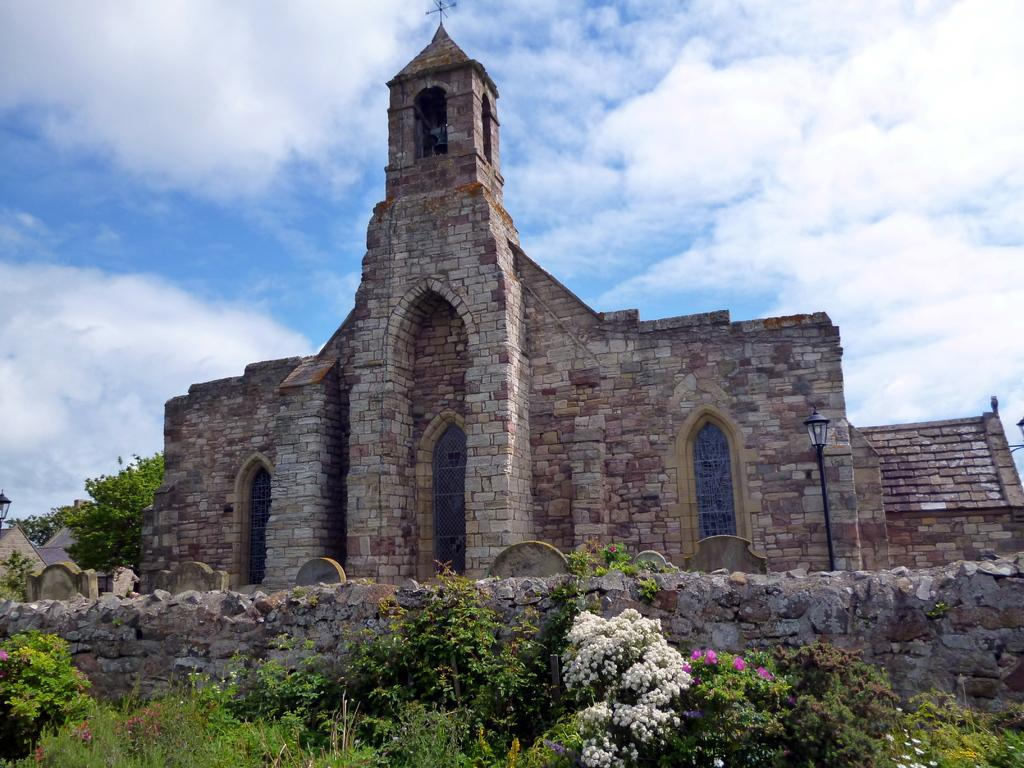What type of plants are at the bottom side of the image? There are flower plants and greenery at the bottom side of the image. What is the main structure in the center of the image? There is a stone castle in the center of the image. What can be seen in the background area of the image? There is a lamp, a tree, and the sky visible in the background area. Where is the cat sitting in the image? There is no cat present in the image. What type of jar is visible in the image? There is no jar present in the image. 